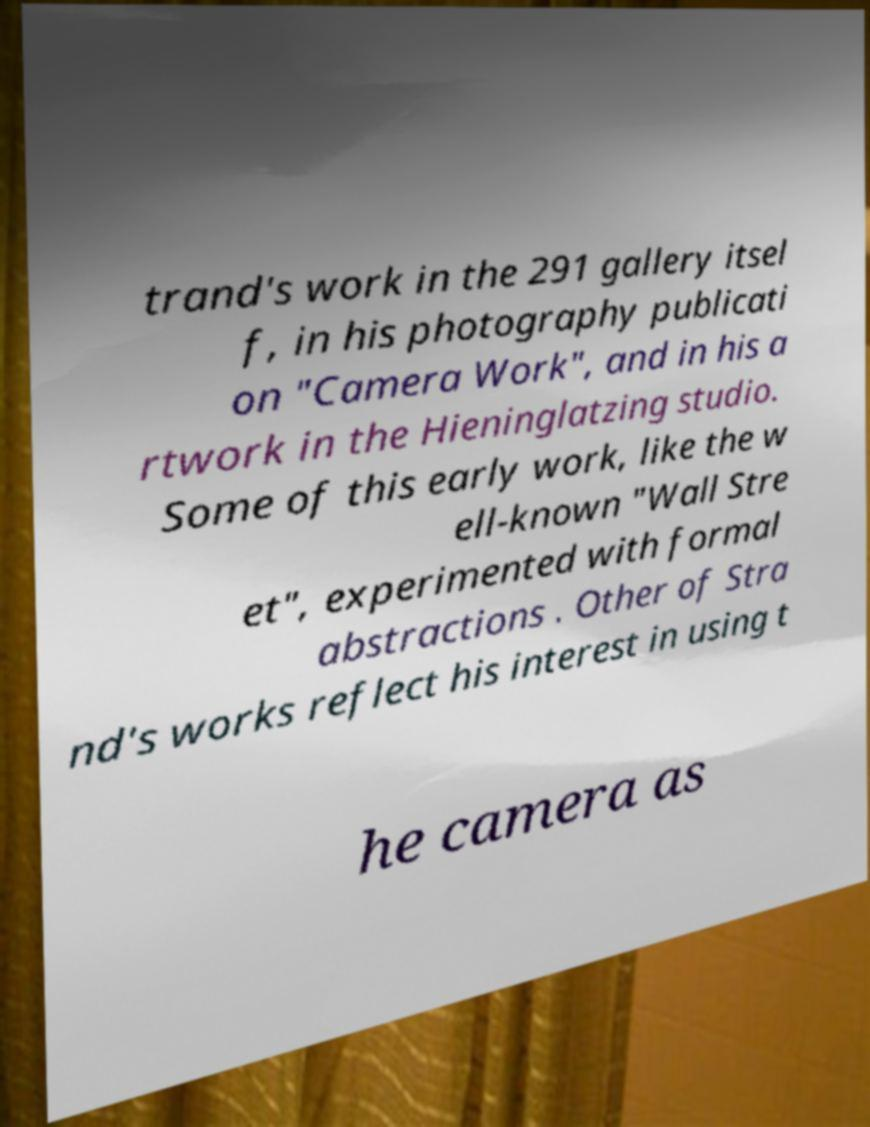Please read and relay the text visible in this image. What does it say? trand's work in the 291 gallery itsel f, in his photography publicati on "Camera Work", and in his a rtwork in the Hieninglatzing studio. Some of this early work, like the w ell-known "Wall Stre et", experimented with formal abstractions . Other of Stra nd's works reflect his interest in using t he camera as 